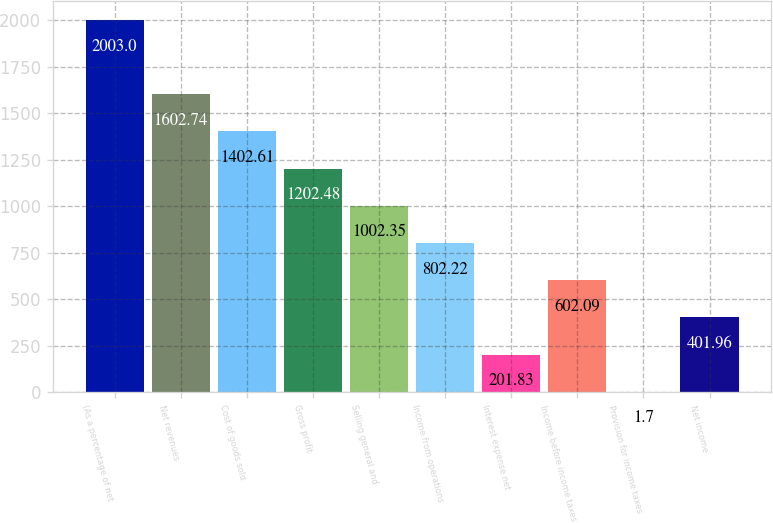Convert chart to OTSL. <chart><loc_0><loc_0><loc_500><loc_500><bar_chart><fcel>(As a percentage of net<fcel>Net revenues<fcel>Cost of goods sold<fcel>Gross profit<fcel>Selling general and<fcel>Income from operations<fcel>Interest expense net<fcel>Income before income taxes<fcel>Provision for income taxes<fcel>Net income<nl><fcel>2003<fcel>1602.74<fcel>1402.61<fcel>1202.48<fcel>1002.35<fcel>802.22<fcel>201.83<fcel>602.09<fcel>1.7<fcel>401.96<nl></chart> 